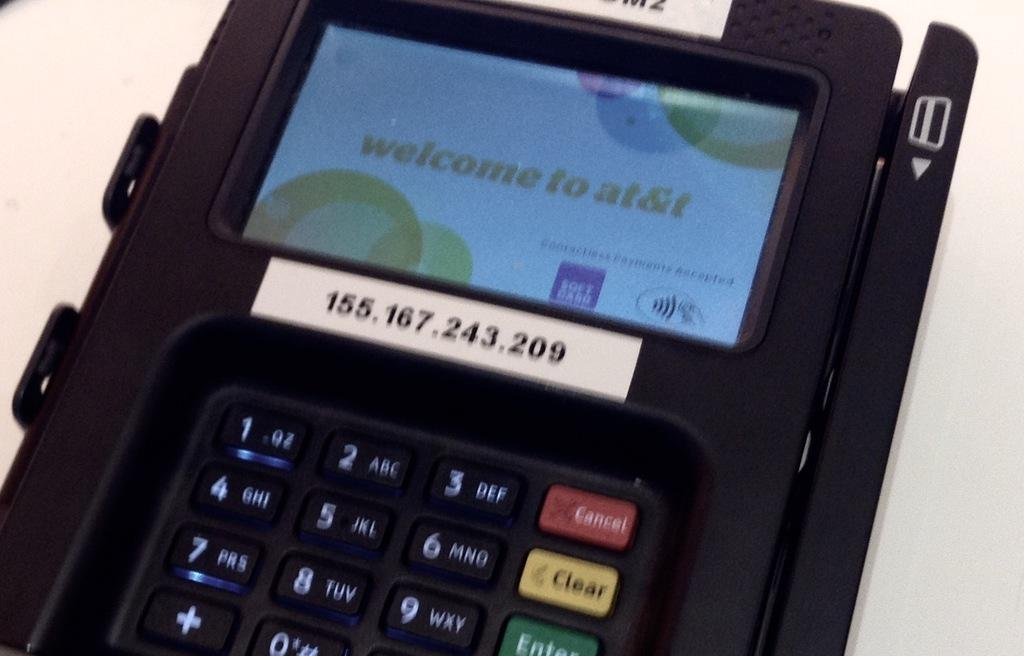<image>
Write a terse but informative summary of the picture. The screen of a credit card processing device says Welcome to AT&T. 